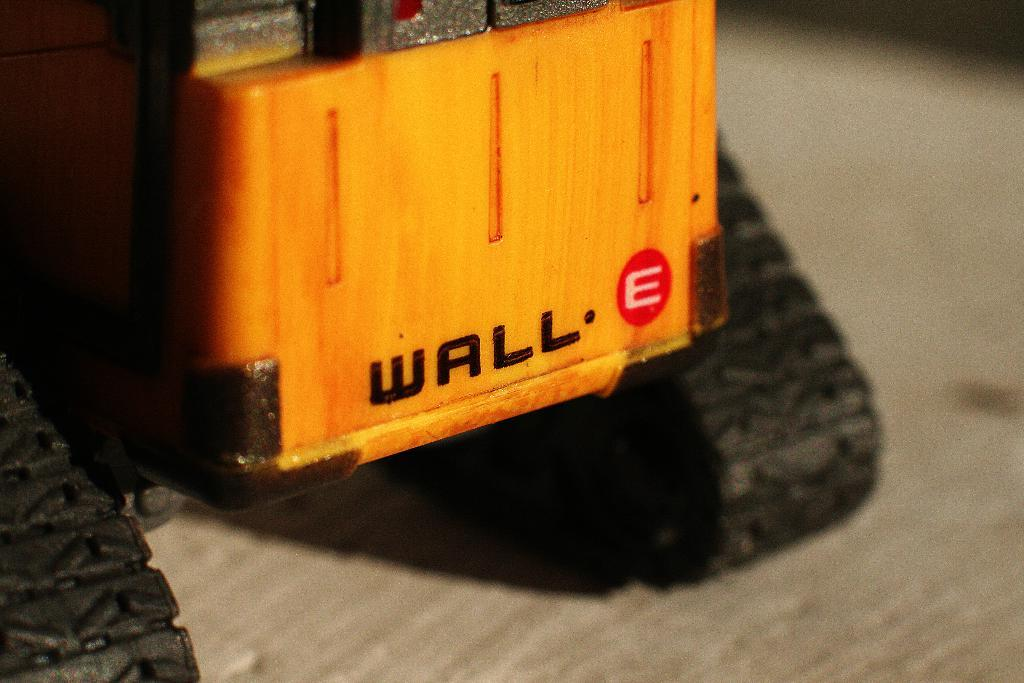What type of toy is present in the image? There is a yellow color excavator toy in the image. Where is the excavator toy located? The excavatorator toy is placed on a table top. What type of trousers is the excavator wearing in the image? The excavator toy is not a living being and does not wear trousers. --- Facts: 1. There is a person holding a book in the image. 2. The book has a blue cover. 3. The person is sitting on a chair. 4. There is a lamp on a table next to the chair. Absurd Topics: elephant, swimming, mountain Conversation: What is the person in the image holding? The person is holding a book in the image. What color is the book's cover? The book has a blue cover. What is the person sitting on in the image? The person is sitting on a chair. What object is present on the table next to the chair? There is a lamp on a table next to the chair. Reasoning: Let's think step by step in order to produce the conversation. We start by identifying the main subject in the image, which is the person holding a book. Then, we describe the book's cover color and the person's seating arrangement. Finally, we mention the presence of a lamp on a table next to the chair. Each question is designed to elicit a specific detail about the image that is known from the provided facts. Absurd Question/Answer: Is the elephant swimming in the mountain behind the person in the image? There is no elephant or mountain present in the image. 